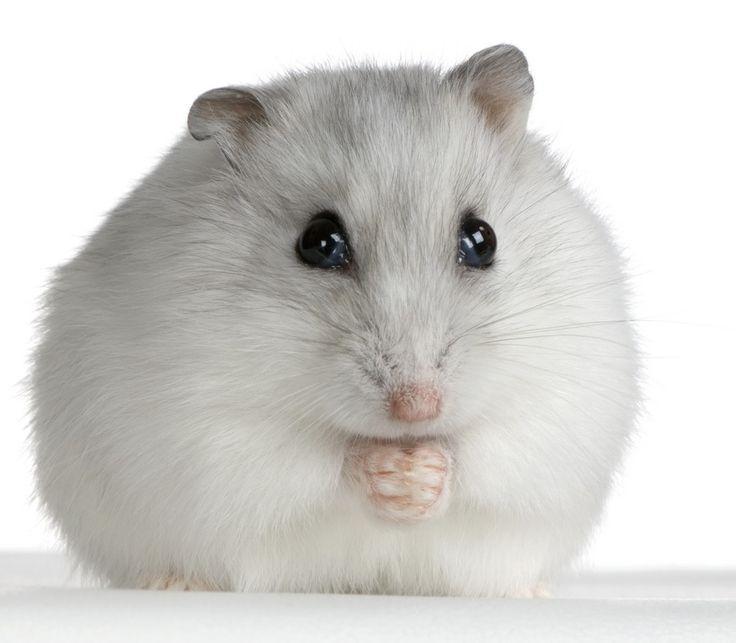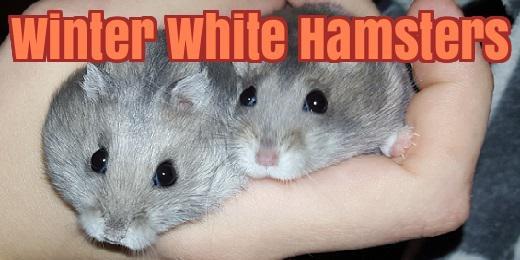The first image is the image on the left, the second image is the image on the right. Assess this claim about the two images: "A single rodent is lying down on a smooth surface in the image on the right.". Correct or not? Answer yes or no. No. The first image is the image on the left, the second image is the image on the right. For the images displayed, is the sentence "Each image contains a single hamster, and at least one hamster is standing upright with its front paws in front of its body." factually correct? Answer yes or no. No. 